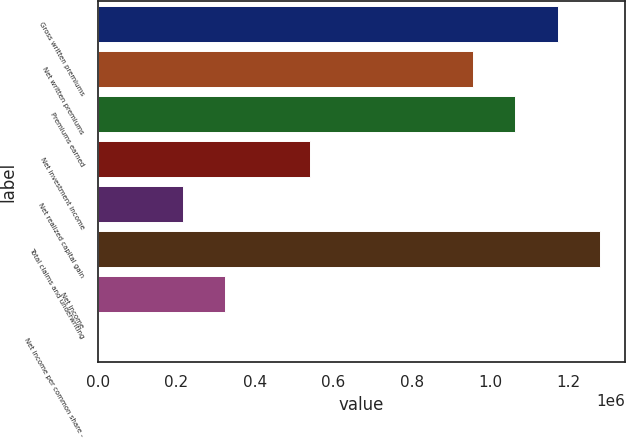Convert chart to OTSL. <chart><loc_0><loc_0><loc_500><loc_500><bar_chart><fcel>Gross written premiums<fcel>Net written premiums<fcel>Premiums earned<fcel>Net investment income<fcel>Net realized capital gain<fcel>Total claims and underwriting<fcel>Net income<fcel>Net income per common share -<nl><fcel>1.17155e+06<fcel>955499<fcel>1.06353e+06<fcel>540139<fcel>216056<fcel>1.27958e+06<fcel>324084<fcel>0.19<nl></chart> 